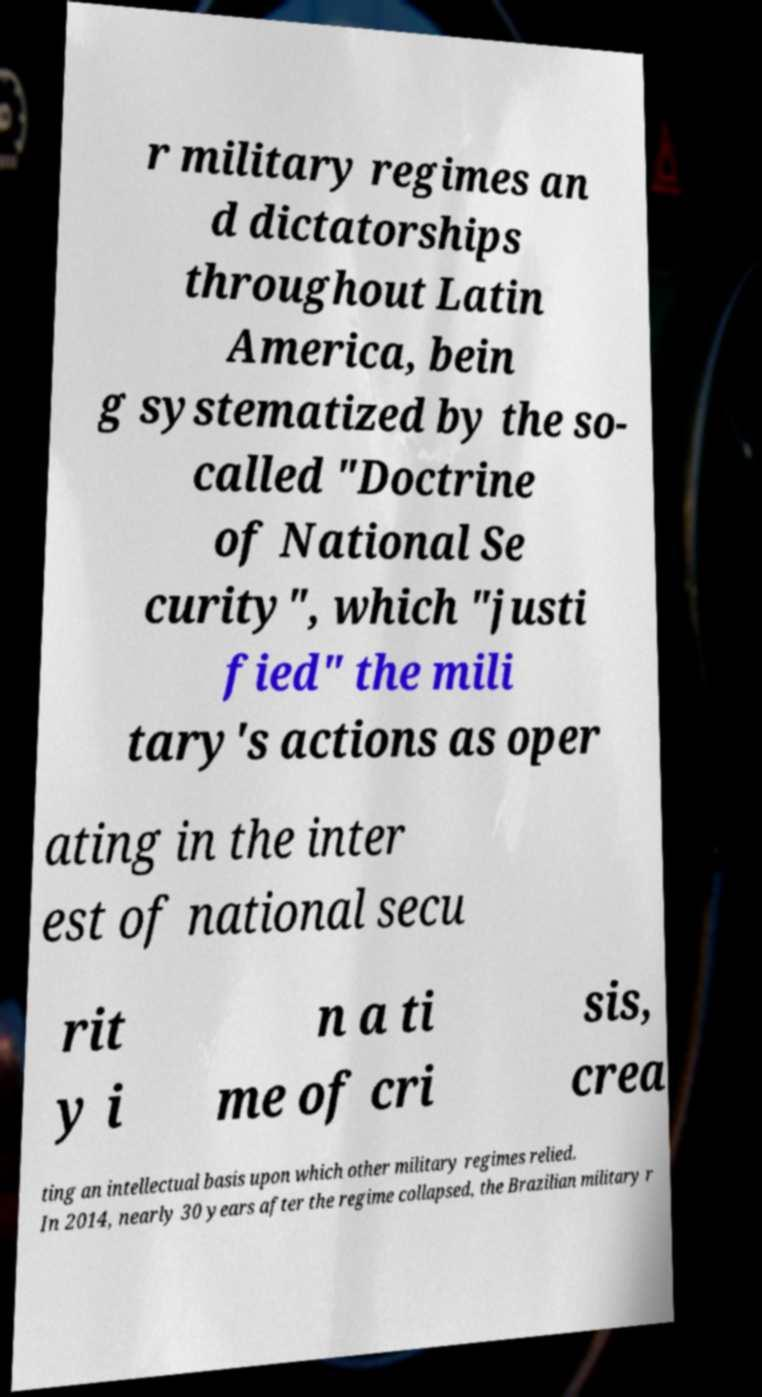Can you accurately transcribe the text from the provided image for me? r military regimes an d dictatorships throughout Latin America, bein g systematized by the so- called "Doctrine of National Se curity", which "justi fied" the mili tary's actions as oper ating in the inter est of national secu rit y i n a ti me of cri sis, crea ting an intellectual basis upon which other military regimes relied. In 2014, nearly 30 years after the regime collapsed, the Brazilian military r 